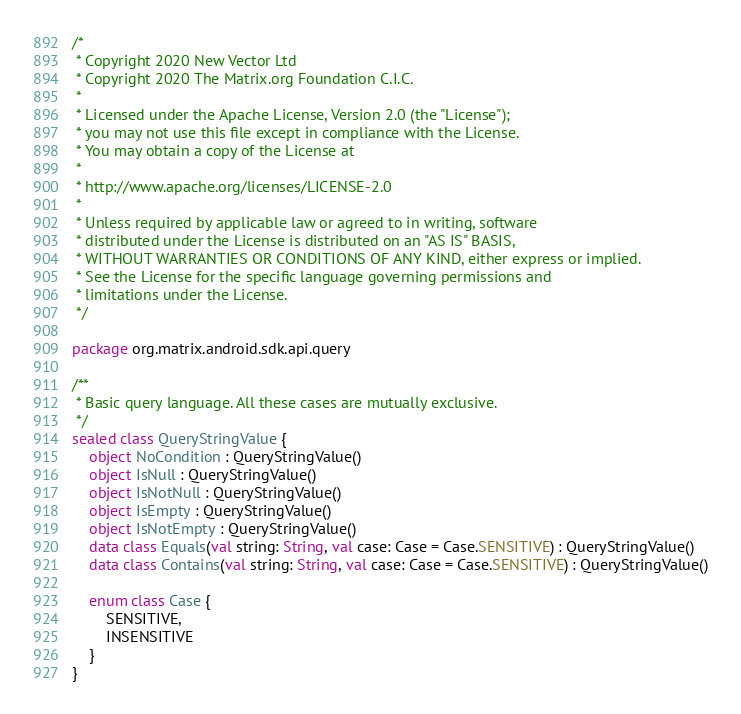Convert code to text. <code><loc_0><loc_0><loc_500><loc_500><_Kotlin_>/*
 * Copyright 2020 New Vector Ltd
 * Copyright 2020 The Matrix.org Foundation C.I.C.
 *
 * Licensed under the Apache License, Version 2.0 (the "License");
 * you may not use this file except in compliance with the License.
 * You may obtain a copy of the License at
 *
 * http://www.apache.org/licenses/LICENSE-2.0
 *
 * Unless required by applicable law or agreed to in writing, software
 * distributed under the License is distributed on an "AS IS" BASIS,
 * WITHOUT WARRANTIES OR CONDITIONS OF ANY KIND, either express or implied.
 * See the License for the specific language governing permissions and
 * limitations under the License.
 */

package org.matrix.android.sdk.api.query

/**
 * Basic query language. All these cases are mutually exclusive.
 */
sealed class QueryStringValue {
    object NoCondition : QueryStringValue()
    object IsNull : QueryStringValue()
    object IsNotNull : QueryStringValue()
    object IsEmpty : QueryStringValue()
    object IsNotEmpty : QueryStringValue()
    data class Equals(val string: String, val case: Case = Case.SENSITIVE) : QueryStringValue()
    data class Contains(val string: String, val case: Case = Case.SENSITIVE) : QueryStringValue()

    enum class Case {
        SENSITIVE,
        INSENSITIVE
    }
}
</code> 